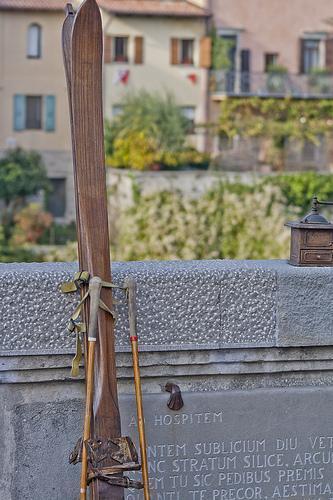How many poles are shown?
Give a very brief answer. 2. 